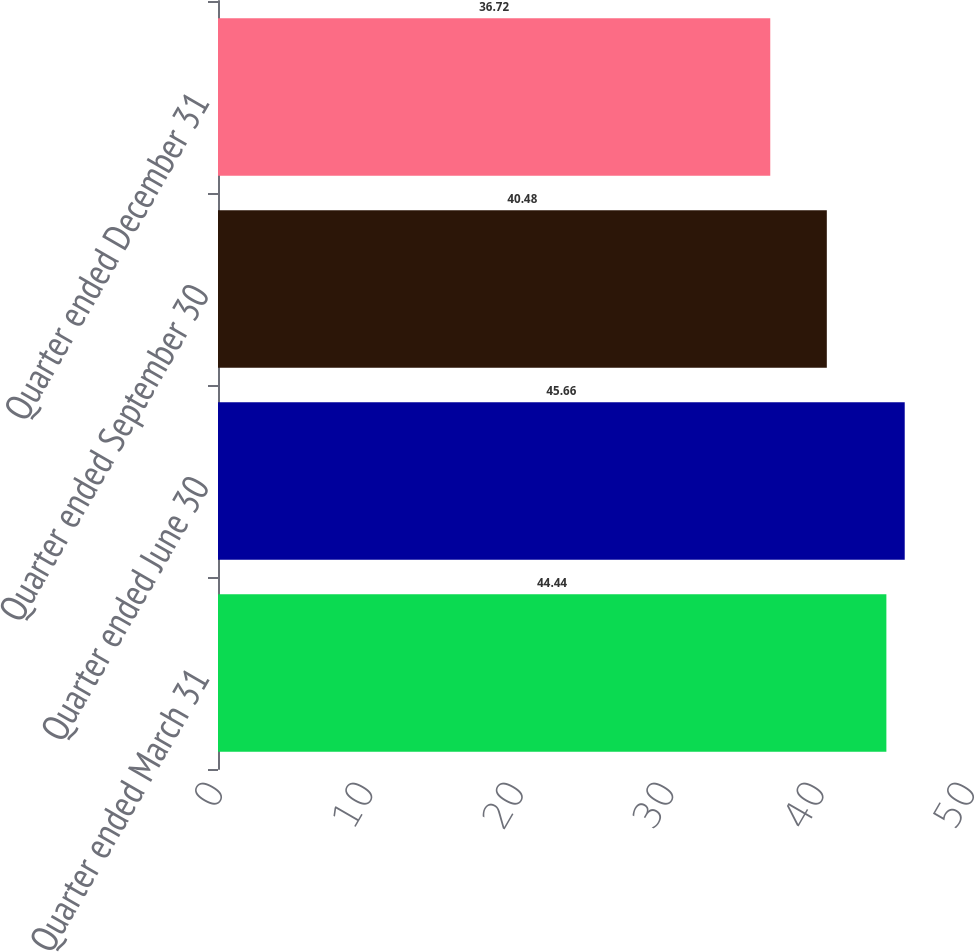Convert chart. <chart><loc_0><loc_0><loc_500><loc_500><bar_chart><fcel>Quarter ended March 31<fcel>Quarter ended June 30<fcel>Quarter ended September 30<fcel>Quarter ended December 31<nl><fcel>44.44<fcel>45.66<fcel>40.48<fcel>36.72<nl></chart> 